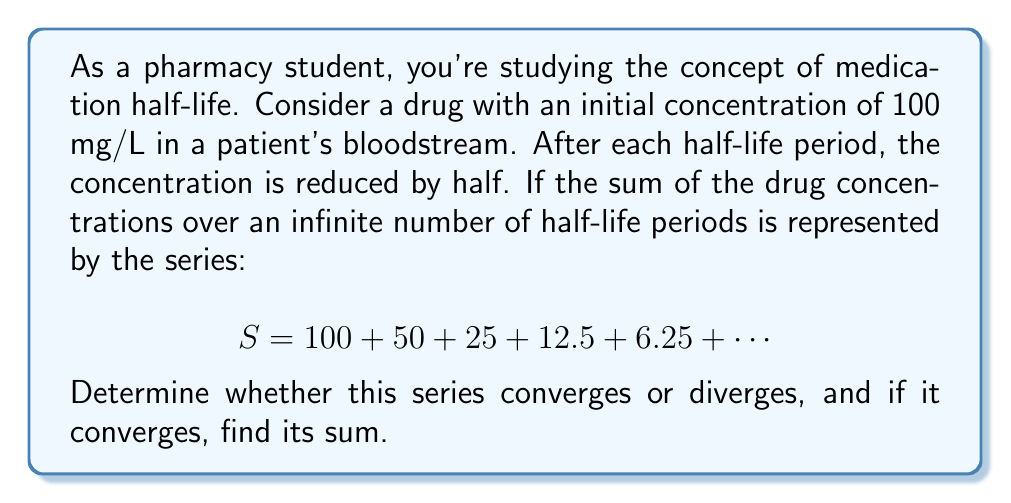Solve this math problem. To determine the convergence and sum of this series, we can follow these steps:

1) First, recognize that this is a geometric series with first term $a = 100$ and common ratio $r = \frac{1}{2}$.

2) The general form of a geometric series is:

   $$S_{\infty} = a + ar + ar^2 + ar^3 + \cdots$$

3) For a geometric series, we know that it converges if and only if $|r| < 1$. In this case:

   $$|r| = |\frac{1}{2}| = \frac{1}{2} < 1$$

   Therefore, this series converges.

4) For a convergent geometric series with $|r| < 1$, the sum is given by the formula:

   $$S_{\infty} = \frac{a}{1-r}$$

5) Substituting our values:

   $$S_{\infty} = \frac{100}{1-\frac{1}{2}} = \frac{100}{\frac{1}{2}} = 200$$

6) This result makes sense in the context of drug concentration. The sum represents the total exposure to the drug over an infinite time, which is finite due to the decreasing concentrations.
Answer: The series converges, and its sum is 200 mg/L. 